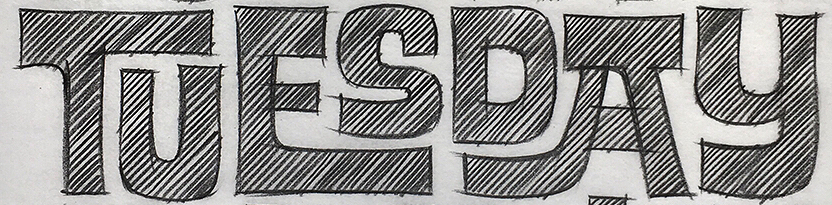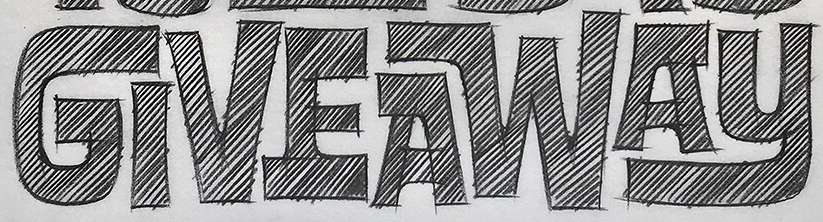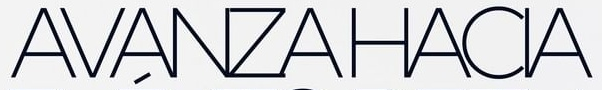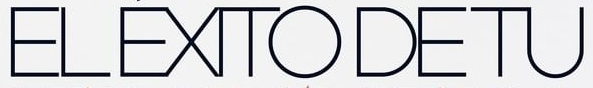Read the text from these images in sequence, separated by a semicolon. TUESDAY; GIVEAWAY; AVANZAHACIA; ELÉXITODETU 